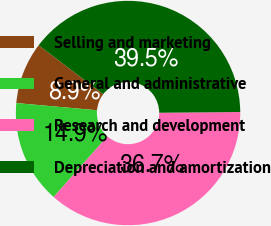<chart> <loc_0><loc_0><loc_500><loc_500><pie_chart><fcel>Selling and marketing<fcel>General and administrative<fcel>Research and development<fcel>Depreciation and amortization<nl><fcel>8.91%<fcel>14.88%<fcel>36.68%<fcel>39.53%<nl></chart> 